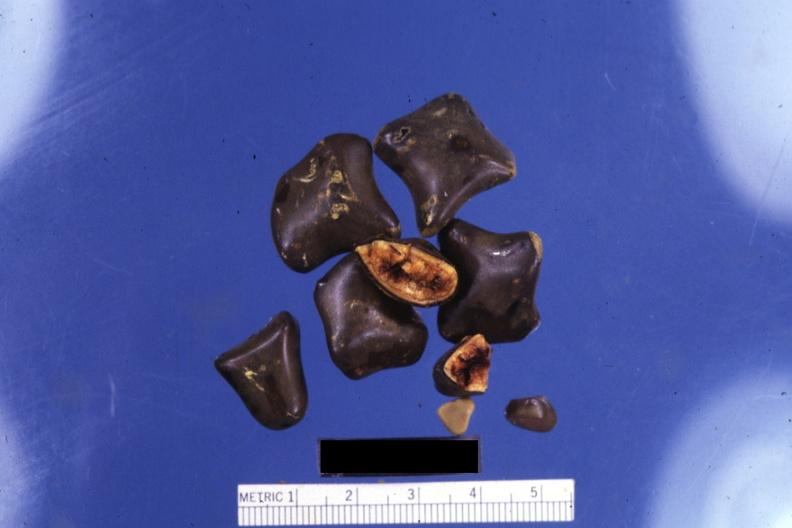does marfans syndrome show close-up of faceted mixed stones with two showing cut surfaces?
Answer the question using a single word or phrase. No 